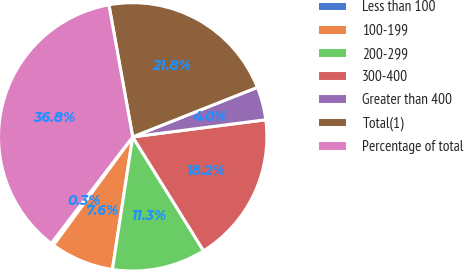Convert chart to OTSL. <chart><loc_0><loc_0><loc_500><loc_500><pie_chart><fcel>Less than 100<fcel>100-199<fcel>200-299<fcel>300-400<fcel>Greater than 400<fcel>Total(1)<fcel>Percentage of total<nl><fcel>0.34%<fcel>7.63%<fcel>11.27%<fcel>18.18%<fcel>3.98%<fcel>21.82%<fcel>36.77%<nl></chart> 